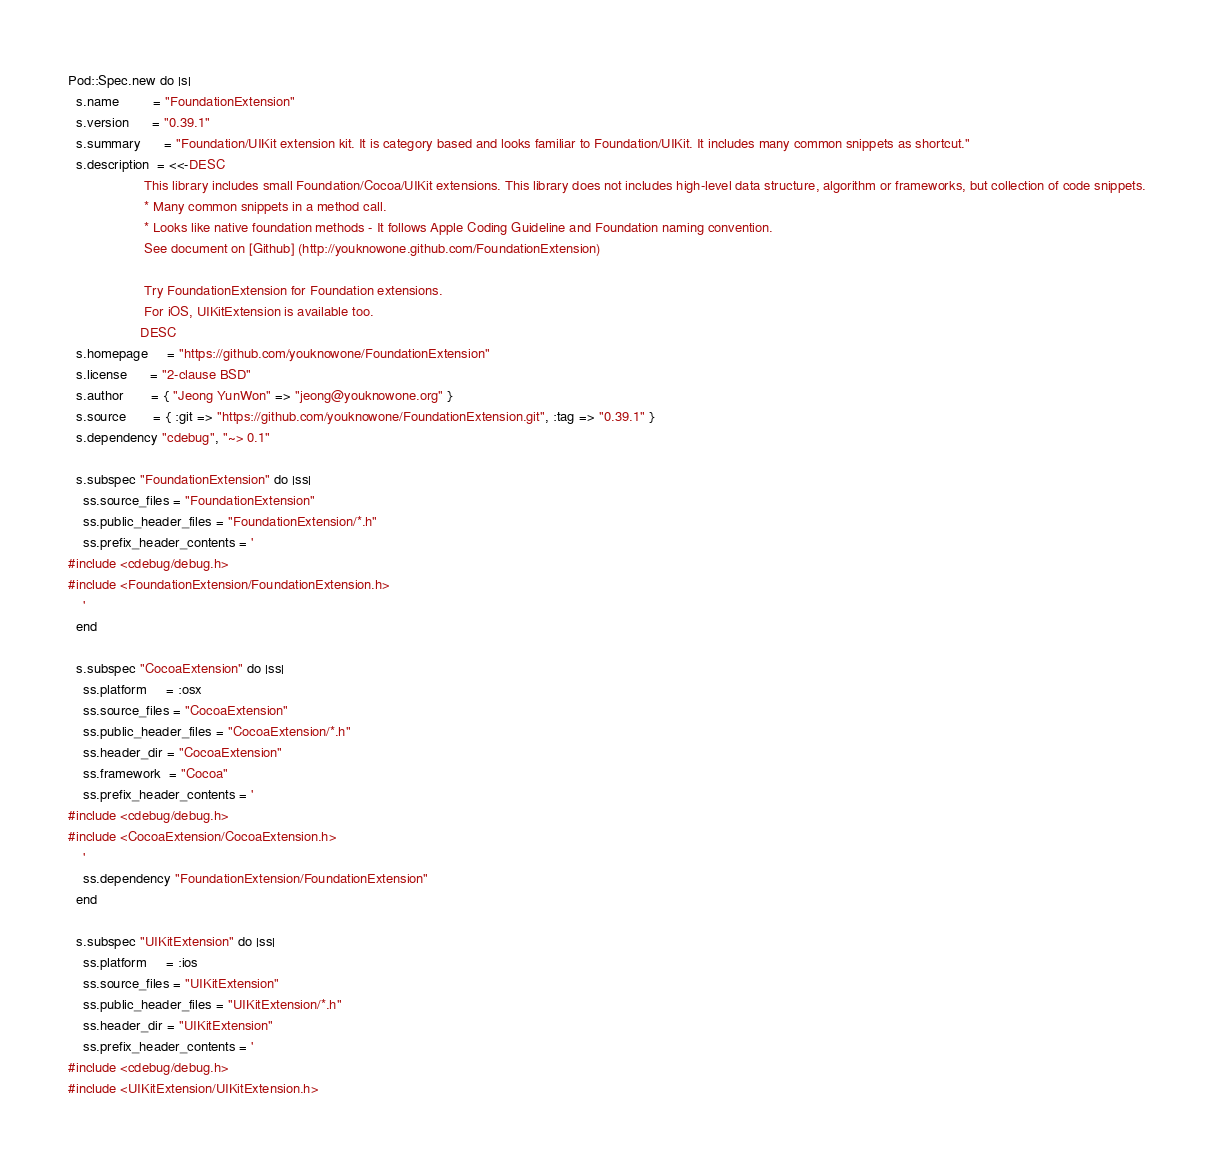Convert code to text. <code><loc_0><loc_0><loc_500><loc_500><_Ruby_>Pod::Spec.new do |s|
  s.name         = "FoundationExtension"
  s.version      = "0.39.1"
  s.summary      = "Foundation/UIKit extension kit. It is category based and looks familiar to Foundation/UIKit. It includes many common snippets as shortcut."
  s.description  = <<-DESC
                    This library includes small Foundation/Cocoa/UIKit extensions. This library does not includes high-level data structure, algorithm or frameworks, but collection of code snippets.
                    * Many common snippets in a method call.
                    * Looks like native foundation methods - It follows Apple Coding Guideline and Foundation naming convention.
                    See document on [Github] (http://youknowone.github.com/FoundationExtension)

                    Try FoundationExtension for Foundation extensions.
                    For iOS, UIKitExtension is available too.
                   DESC
  s.homepage     = "https://github.com/youknowone/FoundationExtension"
  s.license      = "2-clause BSD"
  s.author       = { "Jeong YunWon" => "jeong@youknowone.org" }
  s.source       = { :git => "https://github.com/youknowone/FoundationExtension.git", :tag => "0.39.1" }
  s.dependency "cdebug", "~> 0.1"

  s.subspec "FoundationExtension" do |ss|
    ss.source_files = "FoundationExtension"
    ss.public_header_files = "FoundationExtension/*.h"
    ss.prefix_header_contents = '
#include <cdebug/debug.h>
#include <FoundationExtension/FoundationExtension.h>
    '
  end

  s.subspec "CocoaExtension" do |ss|
    ss.platform     = :osx
    ss.source_files = "CocoaExtension"
    ss.public_header_files = "CocoaExtension/*.h"
    ss.header_dir = "CocoaExtension"
    ss.framework  = "Cocoa"
    ss.prefix_header_contents = '
#include <cdebug/debug.h>
#include <CocoaExtension/CocoaExtension.h>
    '
    ss.dependency "FoundationExtension/FoundationExtension"
  end

  s.subspec "UIKitExtension" do |ss|
    ss.platform     = :ios
    ss.source_files = "UIKitExtension"
    ss.public_header_files = "UIKitExtension/*.h"
    ss.header_dir = "UIKitExtension"
    ss.prefix_header_contents = '
#include <cdebug/debug.h>
#include <UIKitExtension/UIKitExtension.h></code> 